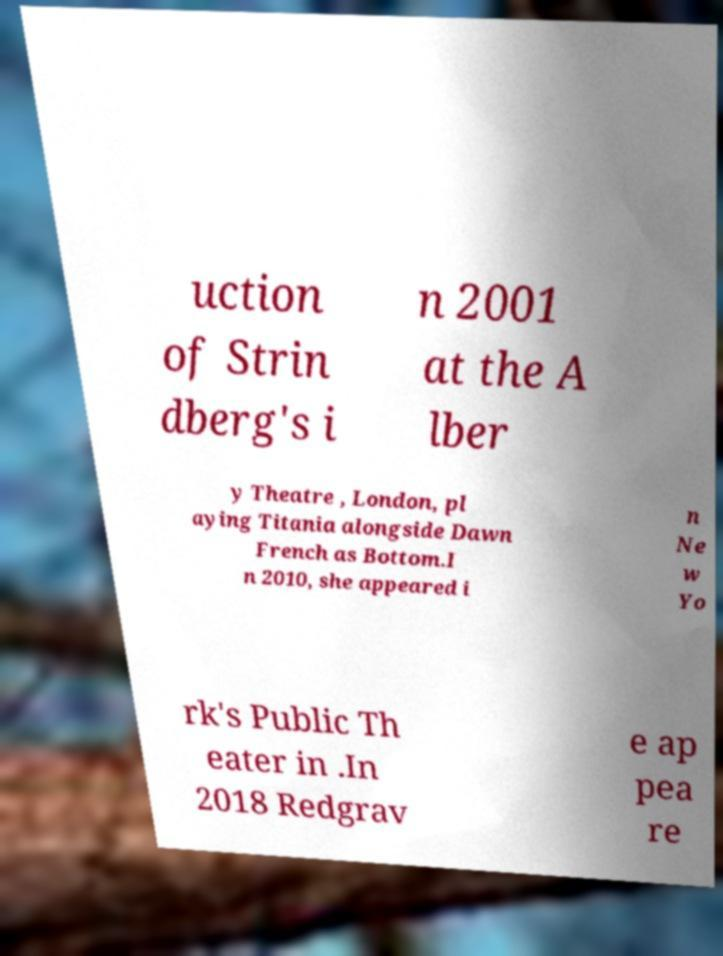Can you accurately transcribe the text from the provided image for me? uction of Strin dberg's i n 2001 at the A lber y Theatre , London, pl aying Titania alongside Dawn French as Bottom.I n 2010, she appeared i n Ne w Yo rk's Public Th eater in .In 2018 Redgrav e ap pea re 